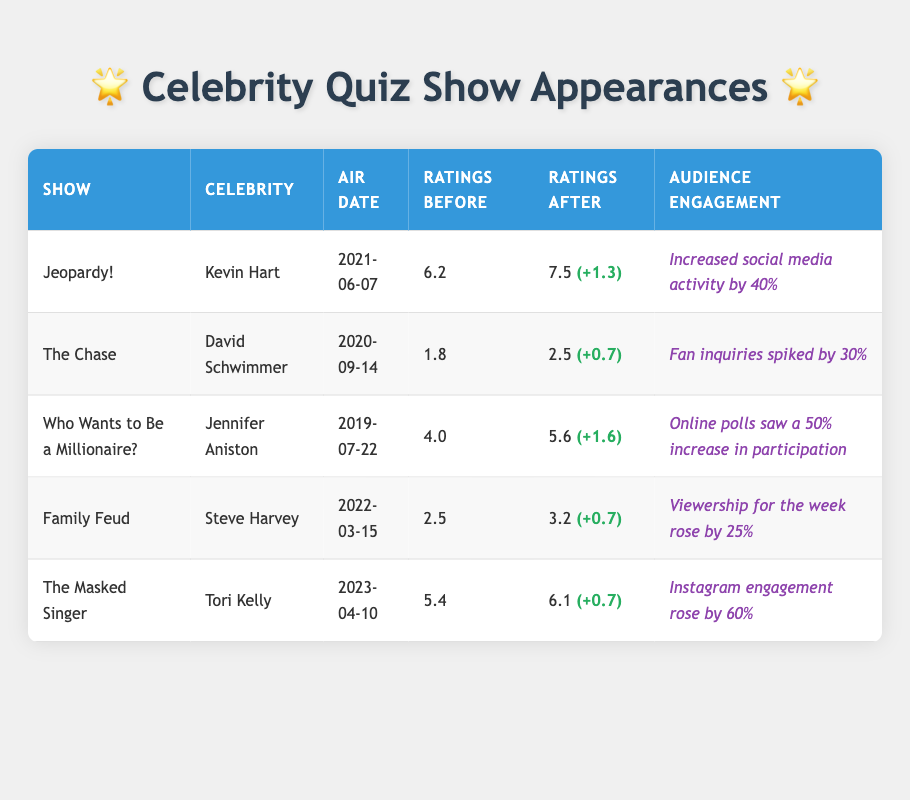What were the ratings before Kevin Hart's appearance on Jeopardy!? The ratings before Kevin Hart's appearance on Jeopardy! are listed in the table as 6.2.
Answer: 6.2 How many total ratings did Jennifer Aniston's appearance increase on Who Wants to Be a Millionaire? To find the increase, subtract the ratings before (4.0) from the ratings after (5.6), which gives us 5.6 - 4.0 = 1.6.
Answer: 1.6 Did Steve Harvey's Family Feud appearance lead to an increase in ratings? Yes, the ratings after (3.2) are greater than the ratings before (2.5), indicating an increase.
Answer: Yes Which celebrity appearance resulted in the highest increase in audience engagement? The table shows that Tori Kelly's appearance on The Masked Singer resulted in a 60% increase in Instagram engagement, which is the highest among all entries.
Answer: Tori Kelly What is the average rating before the celebrity guest appearances? The total ratings before the guest appearances are (6.2 + 1.8 + 4.0 + 2.5 + 5.4) = 19.9. Since there are 5 shows, the average is 19.9 / 5 = 3.98.
Answer: 3.98 Which show had the lowest ratings before a celebrity appearance, and what were those ratings? The Chase had the lowest ratings before a celebrity appearance at 1.8 according to the table.
Answer: The Chase, 1.8 Was there a celebrity appearance that led to a ratings increase of 0.7? Yes, both David Schwimmer on The Chase and Tori Kelly on The Masked Singer had a ratings increase of 0.7.
Answer: Yes What is the total increase in ratings for all celebrity appearances combined? The total increases are 1.3 (Kevin Hart) + 0.7 (David Schwimmer) + 1.6 (Jennifer Aniston) + 0.7 (Steve Harvey) + 0.7 (Tori Kelly) = 5.0.
Answer: 5.0 Which celebrity's appearance had the highest ratings after their episode aired? After their episode, Kevin Hart on Jeopardy! had the highest ratings at 7.5.
Answer: Kevin Hart 